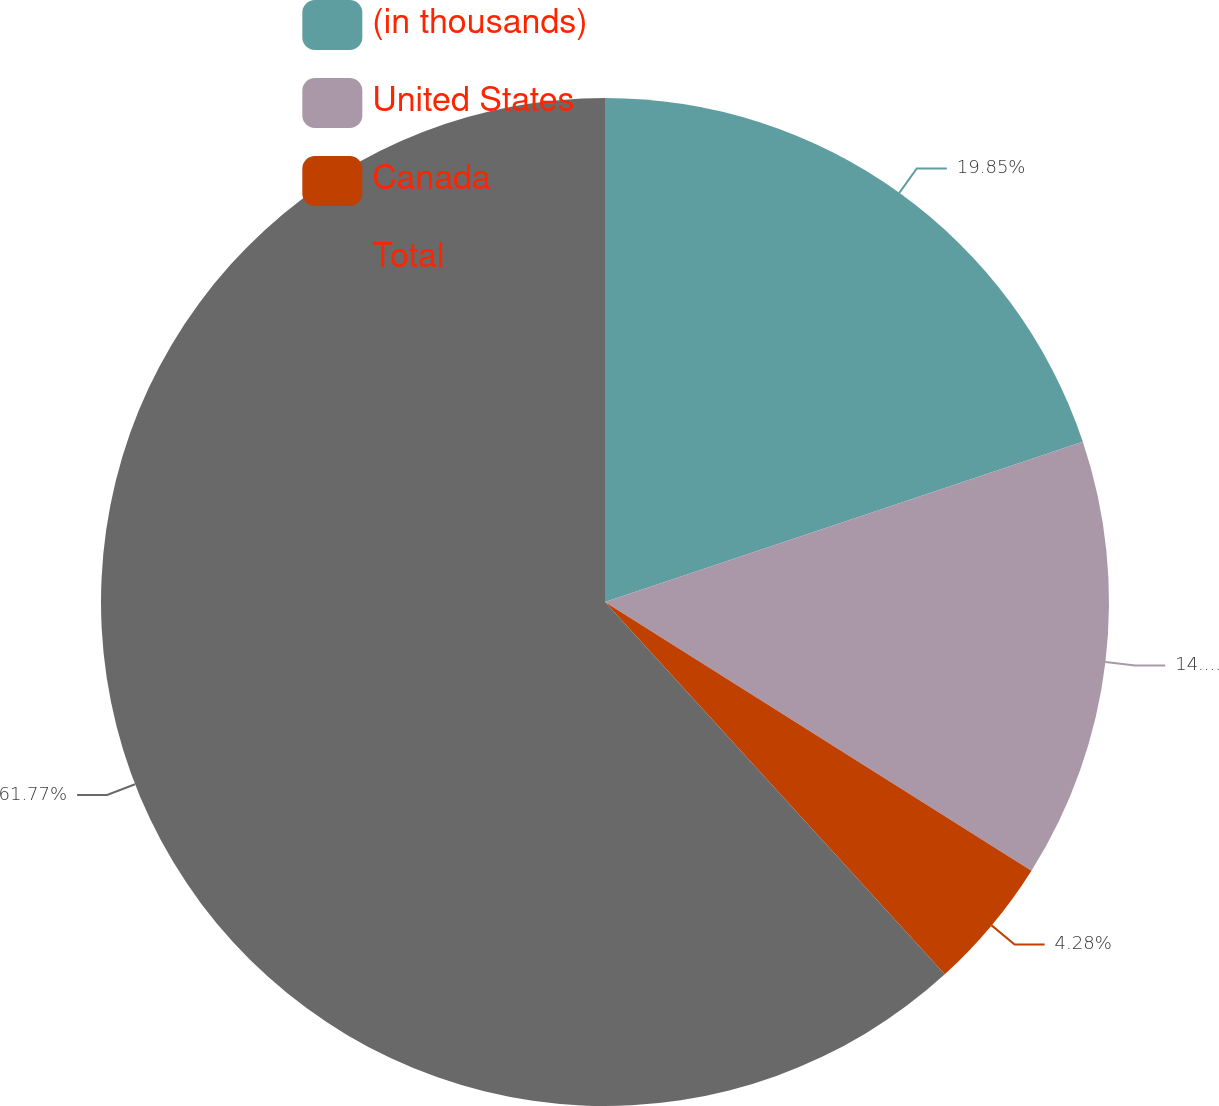<chart> <loc_0><loc_0><loc_500><loc_500><pie_chart><fcel>(in thousands)<fcel>United States<fcel>Canada<fcel>Total<nl><fcel>19.85%<fcel>14.1%<fcel>4.28%<fcel>61.78%<nl></chart> 